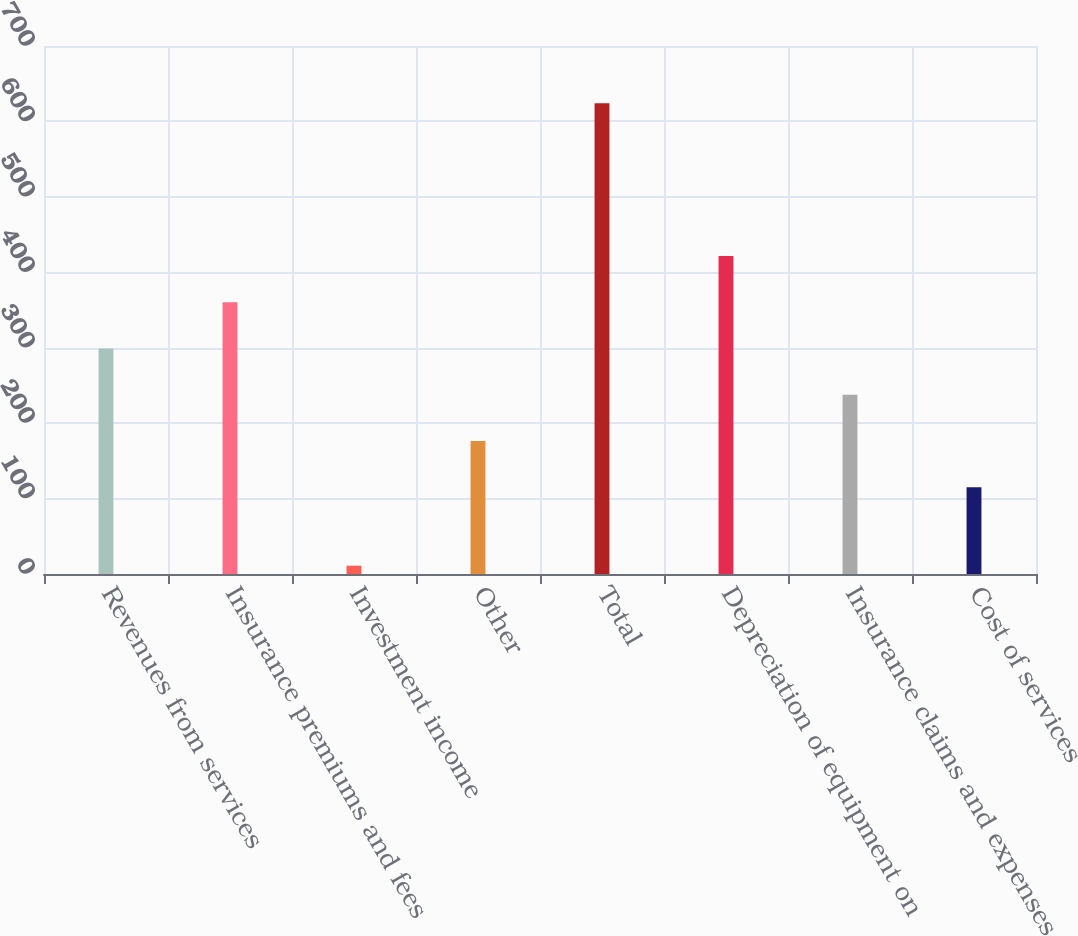Convert chart. <chart><loc_0><loc_0><loc_500><loc_500><bar_chart><fcel>Revenues from services<fcel>Insurance premiums and fees<fcel>Investment income<fcel>Other<fcel>Total<fcel>Depreciation of equipment on<fcel>Insurance claims and expenses<fcel>Cost of services<nl><fcel>298.9<fcel>360.2<fcel>11<fcel>176.3<fcel>624<fcel>421.5<fcel>237.6<fcel>115<nl></chart> 